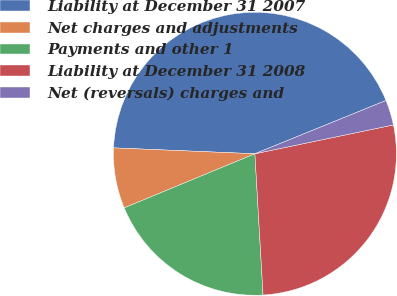<chart> <loc_0><loc_0><loc_500><loc_500><pie_chart><fcel>Liability at December 31 2007<fcel>Net charges and adjustments<fcel>Payments and other 1<fcel>Liability at December 31 2008<fcel>Net (reversals) charges and<nl><fcel>43.19%<fcel>6.91%<fcel>19.67%<fcel>27.35%<fcel>2.88%<nl></chart> 